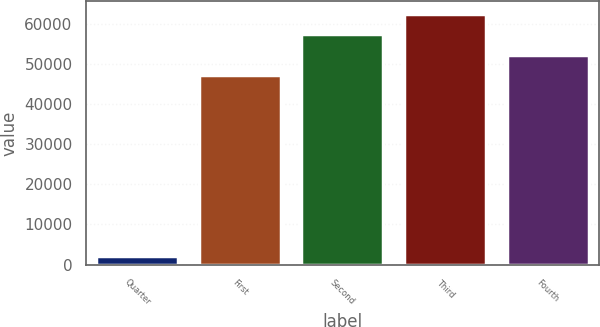Convert chart. <chart><loc_0><loc_0><loc_500><loc_500><bar_chart><fcel>Quarter<fcel>First<fcel>Second<fcel>Third<fcel>Fourth<nl><fcel>2009<fcel>47197<fcel>57355.2<fcel>62434.3<fcel>52276.1<nl></chart> 